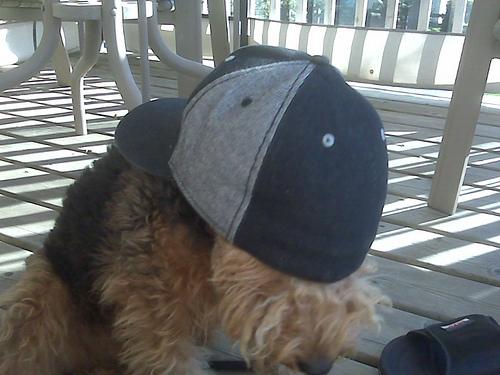What is on the dog's head?
Short answer required. Hat. Can you see the dog eyes?
Write a very short answer. No. What color hat is this animal wearing?
Be succinct. Black and gray. 